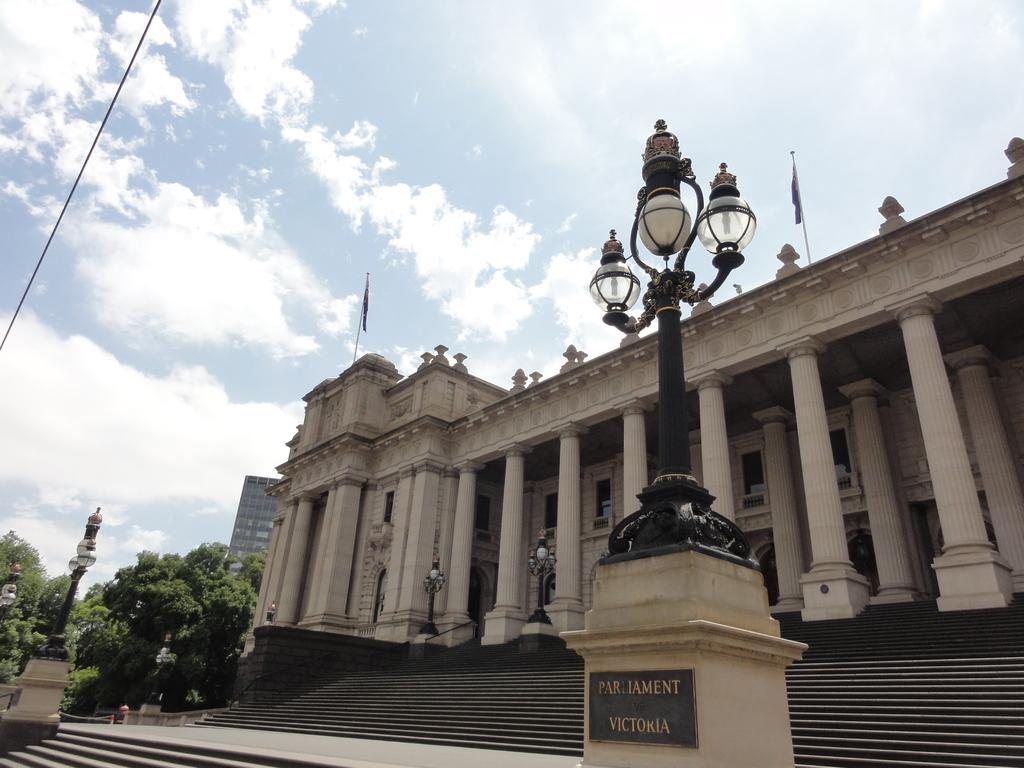What is the main subject in the center of the image? There is a parliament house in the center of the image. What can be seen on the left side of the image? There are trees on the left side of the image. Is there a feast taking place in front of the parliament house in the image? There is no indication of a feast or any gathering of people in the image. 